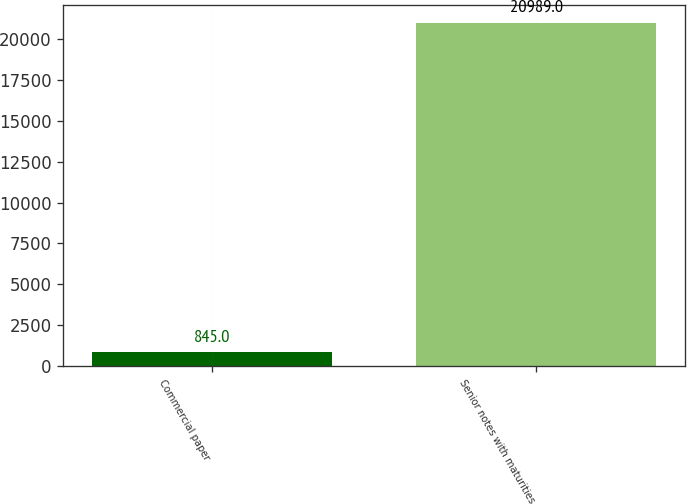Convert chart. <chart><loc_0><loc_0><loc_500><loc_500><bar_chart><fcel>Commercial paper<fcel>Senior notes with maturities<nl><fcel>845<fcel>20989<nl></chart> 